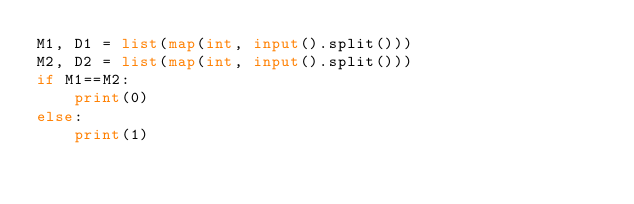<code> <loc_0><loc_0><loc_500><loc_500><_Python_>M1, D1 = list(map(int, input().split()))
M2, D2 = list(map(int, input().split()))
if M1==M2:
    print(0)
else:
    print(1)</code> 